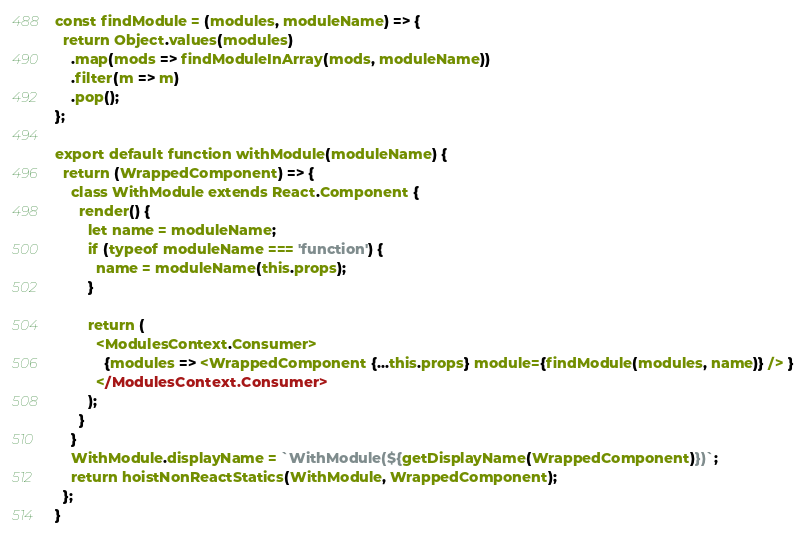Convert code to text. <code><loc_0><loc_0><loc_500><loc_500><_JavaScript_>const findModule = (modules, moduleName) => {
  return Object.values(modules)
    .map(mods => findModuleInArray(mods, moduleName))
    .filter(m => m)
    .pop();
};

export default function withModule(moduleName) {
  return (WrappedComponent) => {
    class WithModule extends React.Component {
      render() {
        let name = moduleName;
        if (typeof moduleName === 'function') {
          name = moduleName(this.props);
        }

        return (
          <ModulesContext.Consumer>
            {modules => <WrappedComponent {...this.props} module={findModule(modules, name)} /> }
          </ModulesContext.Consumer>
        );
      }
    }
    WithModule.displayName = `WithModule(${getDisplayName(WrappedComponent)})`;
    return hoistNonReactStatics(WithModule, WrappedComponent);
  };
}
</code> 